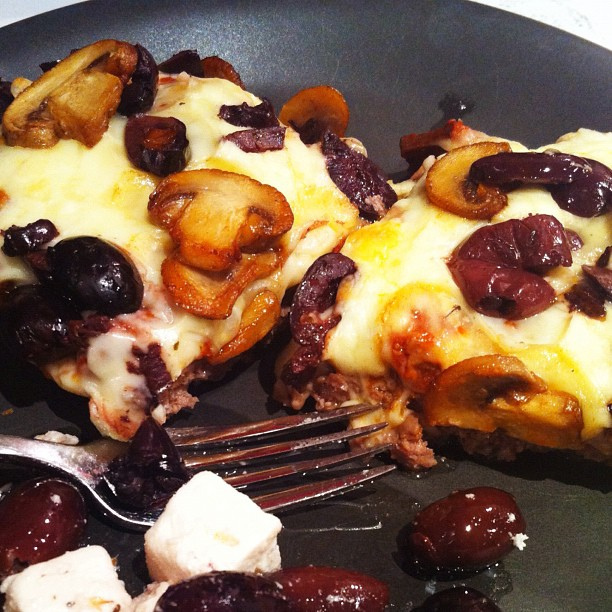<image>Has someone taken a bite of this meal? I am unsure if someone has taken a bite of this meal. Has someone taken a bite of this meal? I am not sure if someone has taken a bite of this meal. It can be seen both yes and no. 